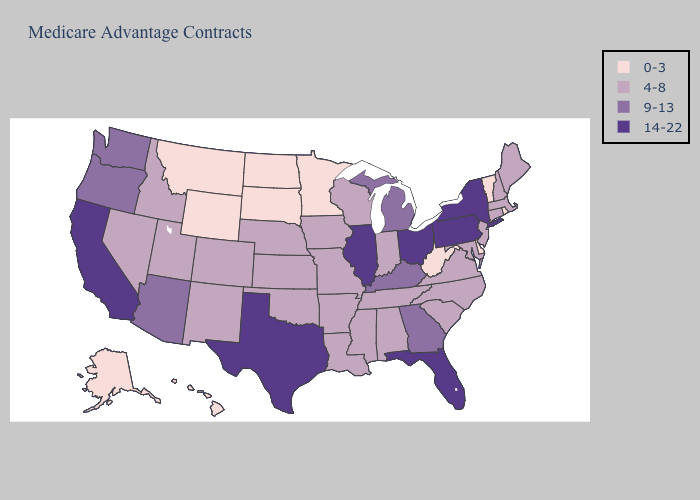Among the states that border North Dakota , which have the highest value?
Short answer required. Minnesota, Montana, South Dakota. Does Illinois have the highest value in the MidWest?
Answer briefly. Yes. Does Ohio have the highest value in the USA?
Give a very brief answer. Yes. Does Michigan have the same value as Georgia?
Give a very brief answer. Yes. What is the value of Michigan?
Answer briefly. 9-13. What is the value of Pennsylvania?
Be succinct. 14-22. Name the states that have a value in the range 14-22?
Be succinct. California, Florida, Illinois, New York, Ohio, Pennsylvania, Texas. Is the legend a continuous bar?
Give a very brief answer. No. Does the map have missing data?
Answer briefly. No. Name the states that have a value in the range 14-22?
Give a very brief answer. California, Florida, Illinois, New York, Ohio, Pennsylvania, Texas. Among the states that border Pennsylvania , does New York have the highest value?
Concise answer only. Yes. Name the states that have a value in the range 0-3?
Write a very short answer. Alaska, Delaware, Hawaii, Minnesota, Montana, North Dakota, Rhode Island, South Dakota, Vermont, West Virginia, Wyoming. Which states have the highest value in the USA?
Keep it brief. California, Florida, Illinois, New York, Ohio, Pennsylvania, Texas. Does Arkansas have the lowest value in the South?
Concise answer only. No. Does Maryland have a lower value than New York?
Quick response, please. Yes. 